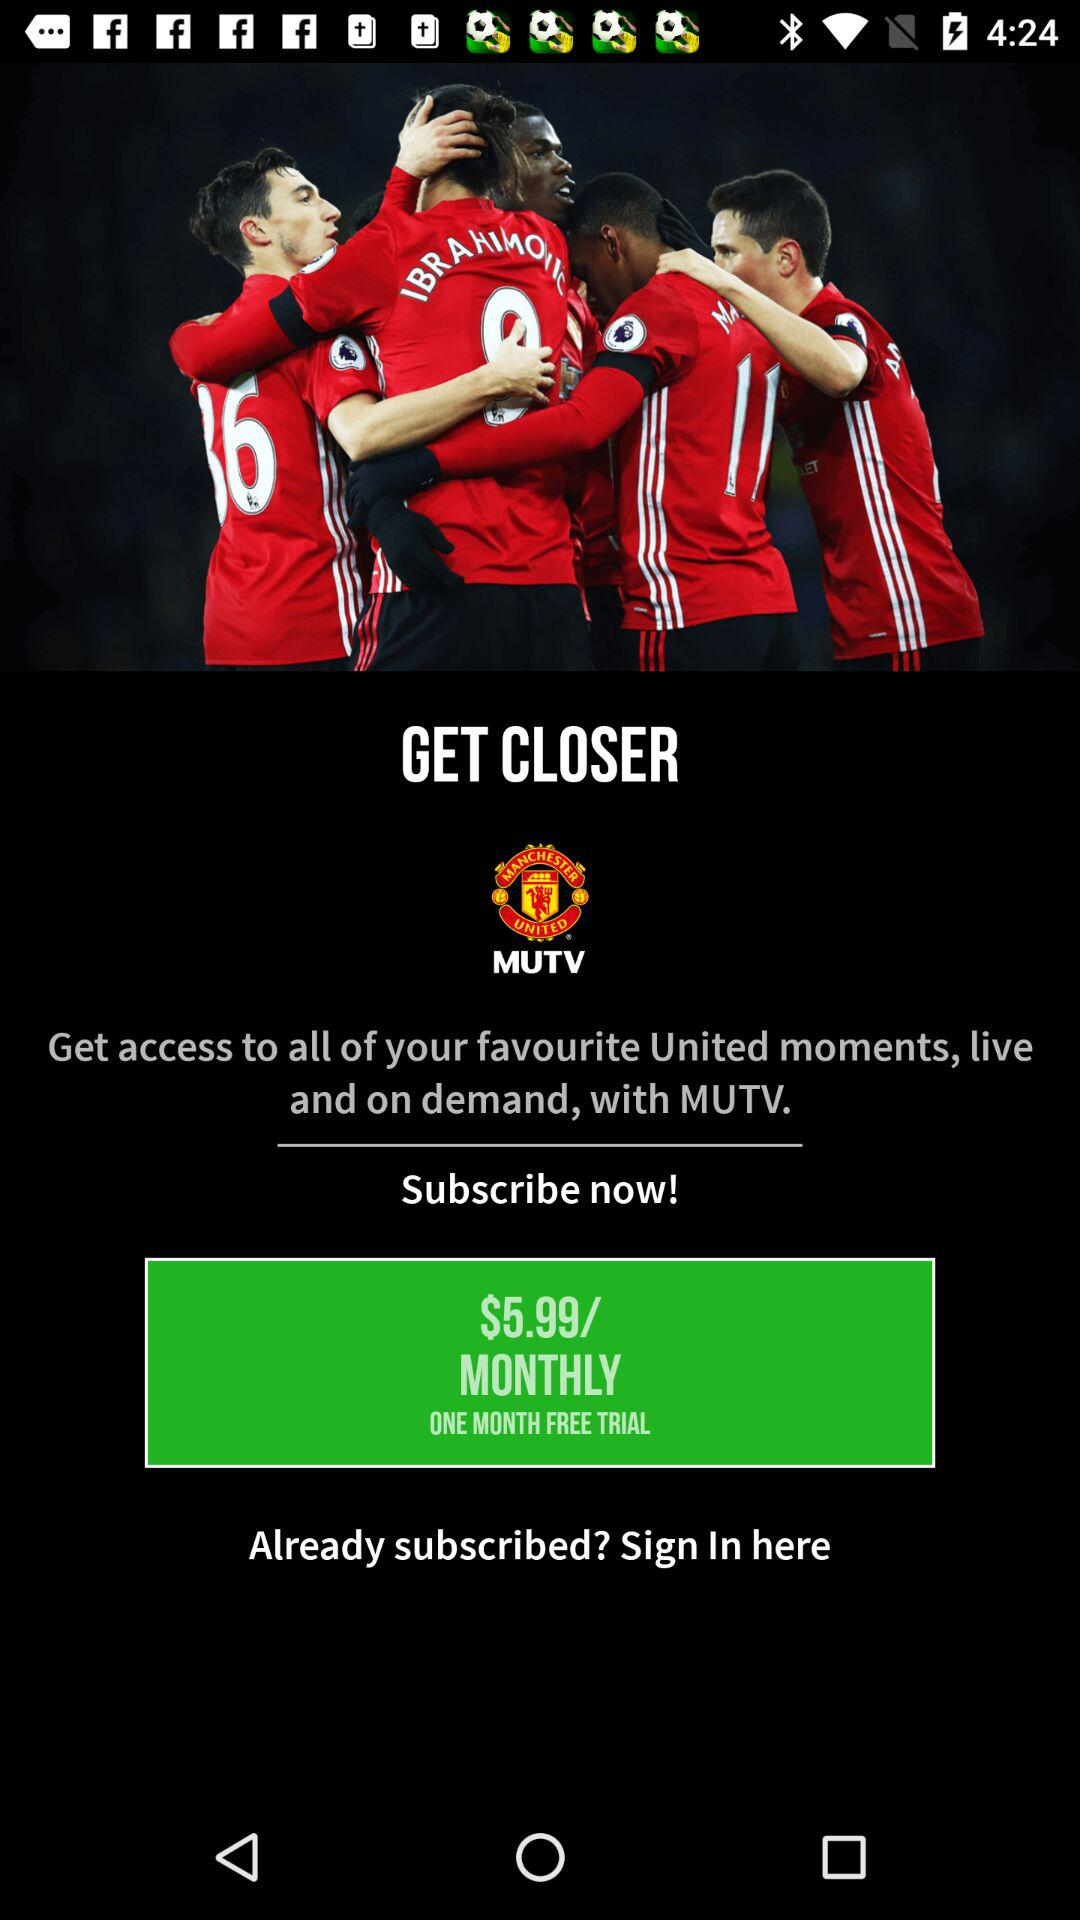What is the per-month cost of the subscription? The per-month cost of the subscription is $5.99. 